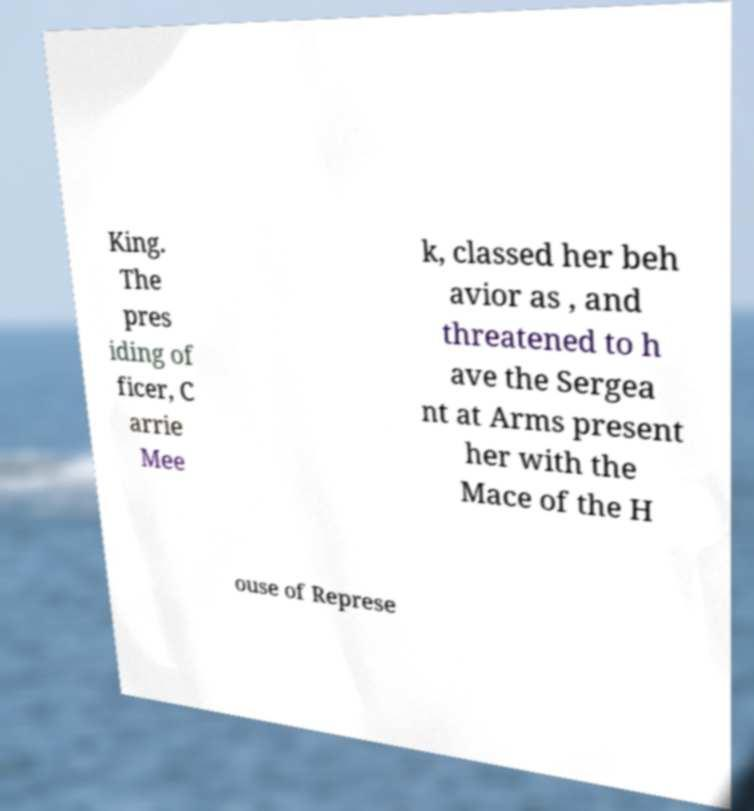Please identify and transcribe the text found in this image. King. The pres iding of ficer, C arrie Mee k, classed her beh avior as , and threatened to h ave the Sergea nt at Arms present her with the Mace of the H ouse of Represe 